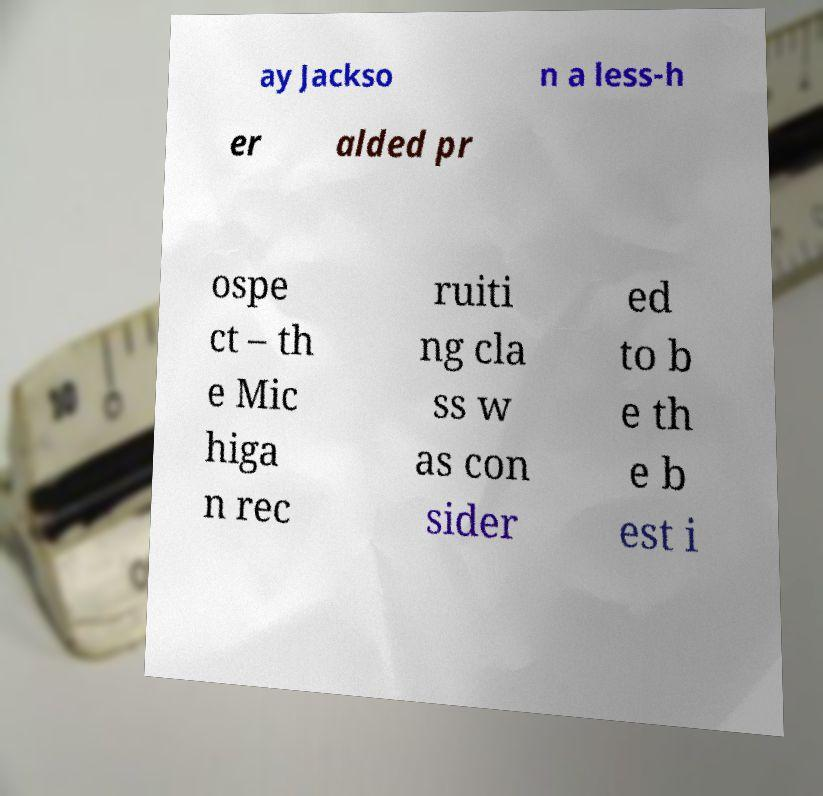Please read and relay the text visible in this image. What does it say? ay Jackso n a less-h er alded pr ospe ct – th e Mic higa n rec ruiti ng cla ss w as con sider ed to b e th e b est i 